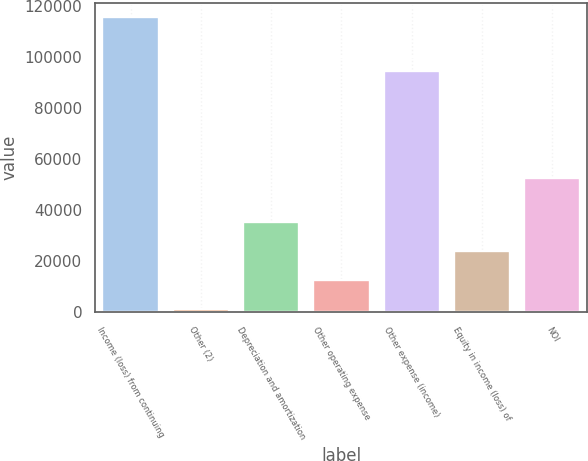Convert chart. <chart><loc_0><loc_0><loc_500><loc_500><bar_chart><fcel>Income (loss) from continuing<fcel>Other (2)<fcel>Depreciation and amortization<fcel>Other operating expense<fcel>Other expense (income)<fcel>Equity in income (loss) of<fcel>NOI<nl><fcel>115440<fcel>1125<fcel>35419.5<fcel>12556.5<fcel>94616<fcel>23988<fcel>52490<nl></chart> 